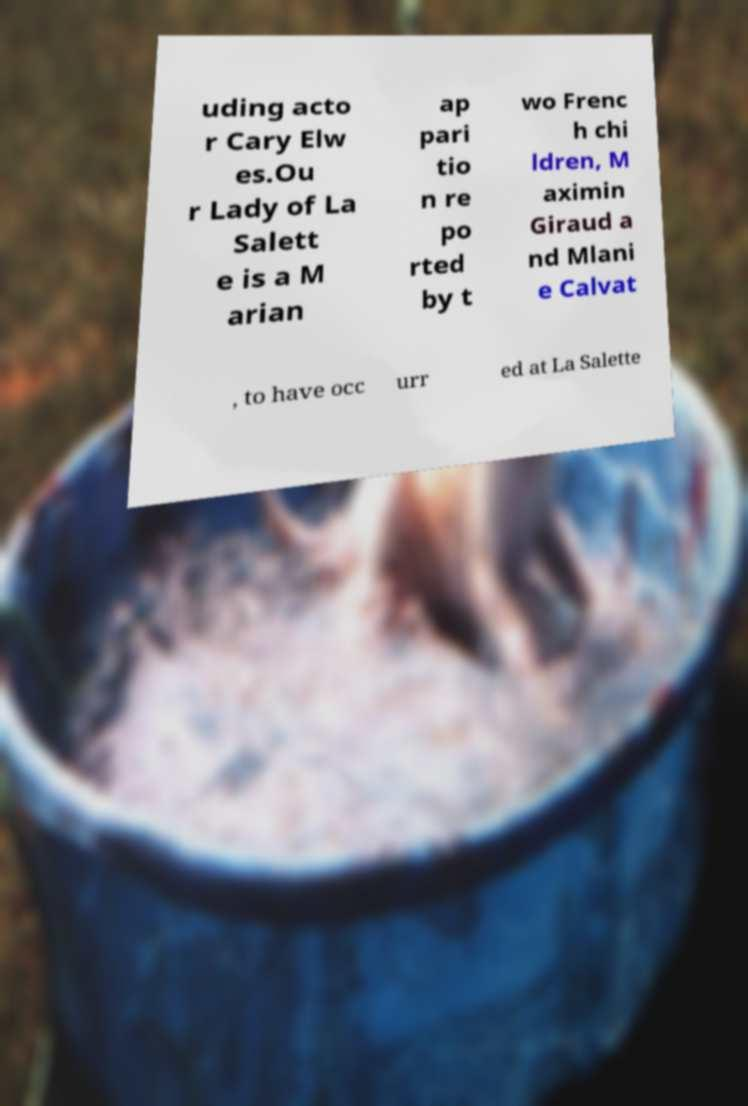Could you assist in decoding the text presented in this image and type it out clearly? uding acto r Cary Elw es.Ou r Lady of La Salett e is a M arian ap pari tio n re po rted by t wo Frenc h chi ldren, M aximin Giraud a nd Mlani e Calvat , to have occ urr ed at La Salette 